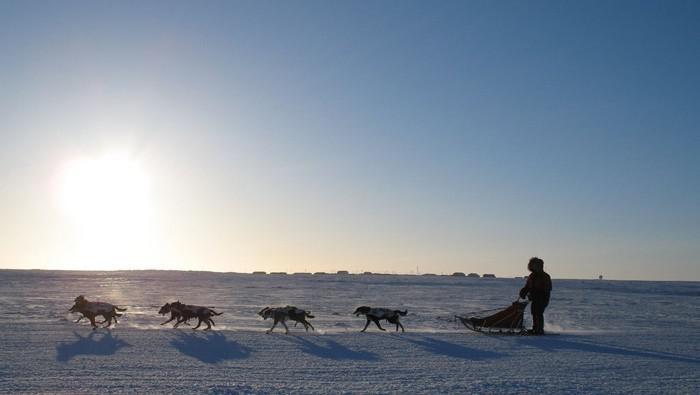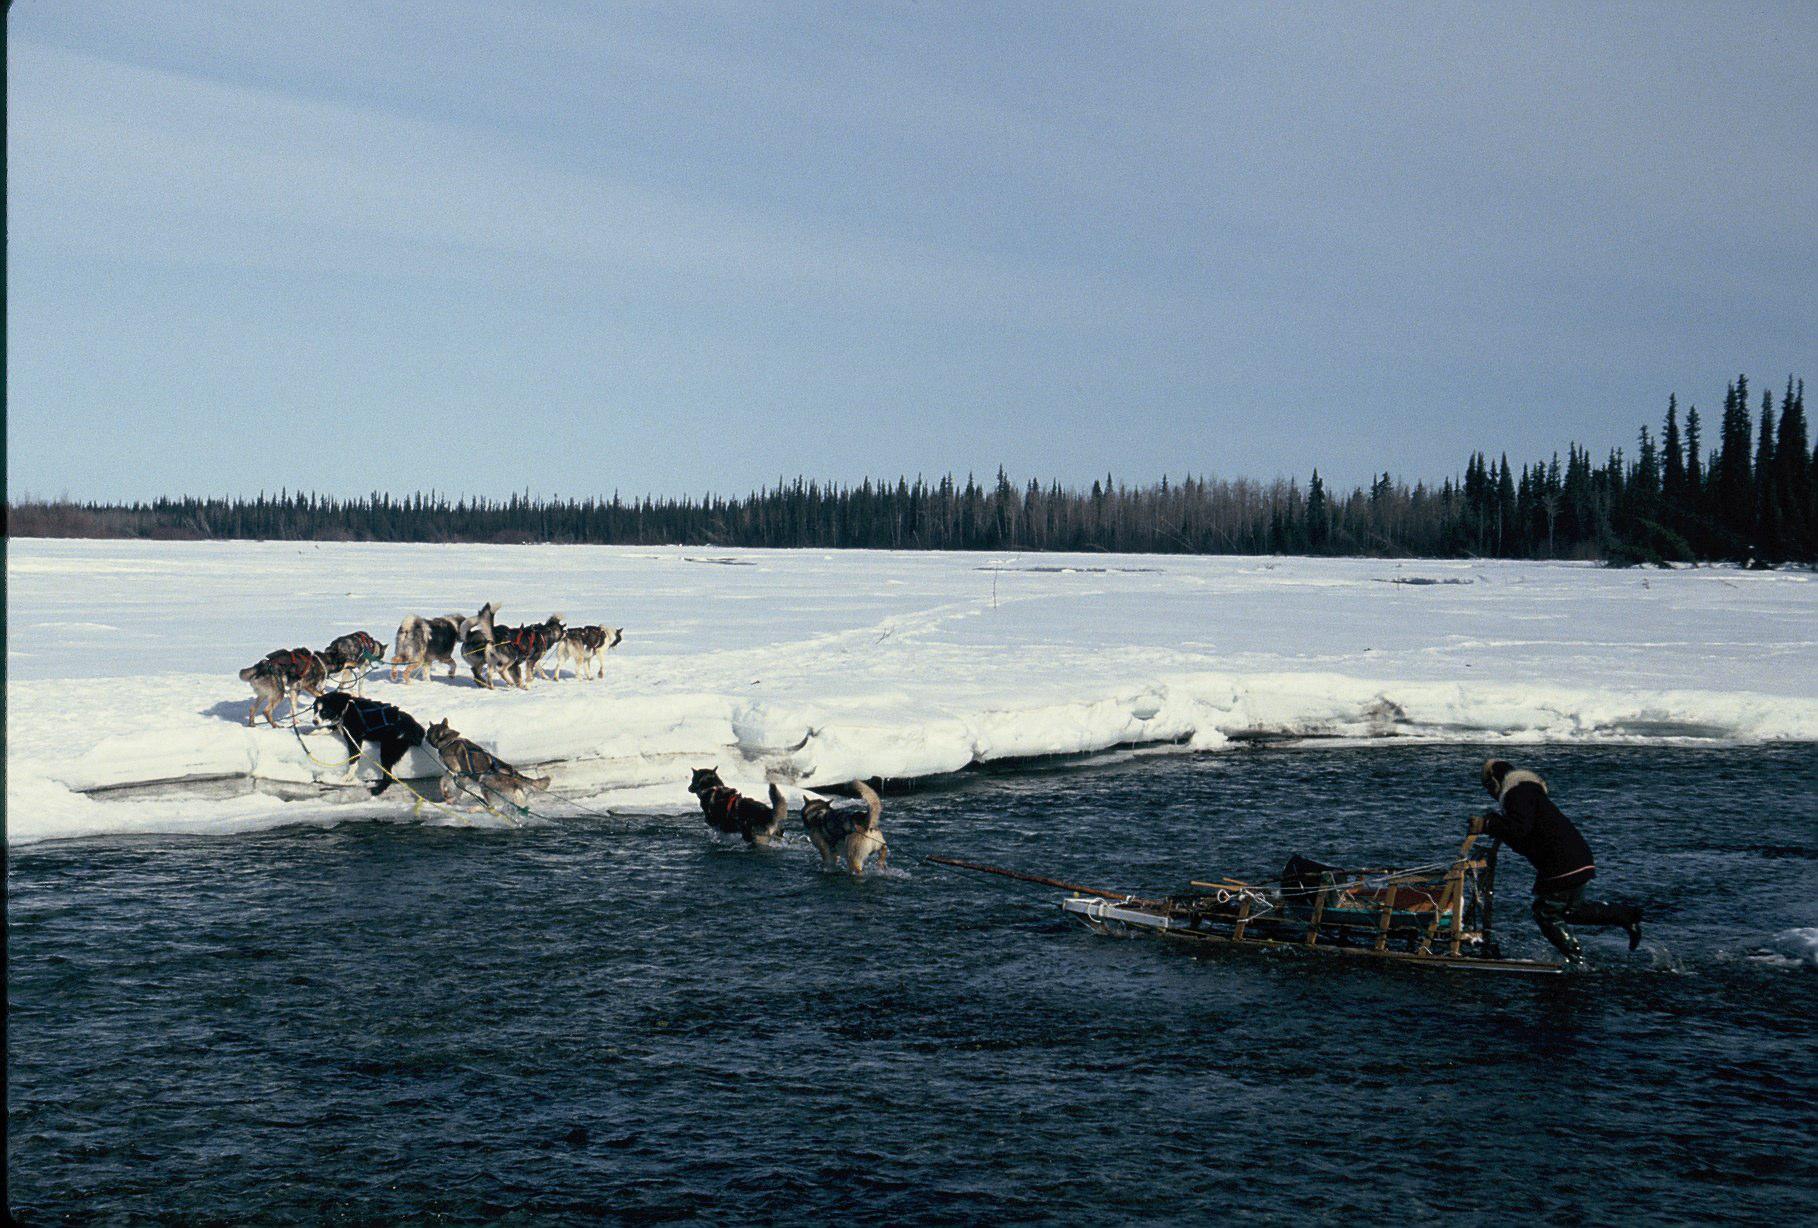The first image is the image on the left, the second image is the image on the right. Analyze the images presented: Is the assertion "In the left image, there's a single team of sled dogs running across the snow to the lower right." valid? Answer yes or no. No. The first image is the image on the left, the second image is the image on the right. For the images displayed, is the sentence "There is at most 2 groups of sleigh dogs pulling a sled to the left in the snow." factually correct? Answer yes or no. Yes. 